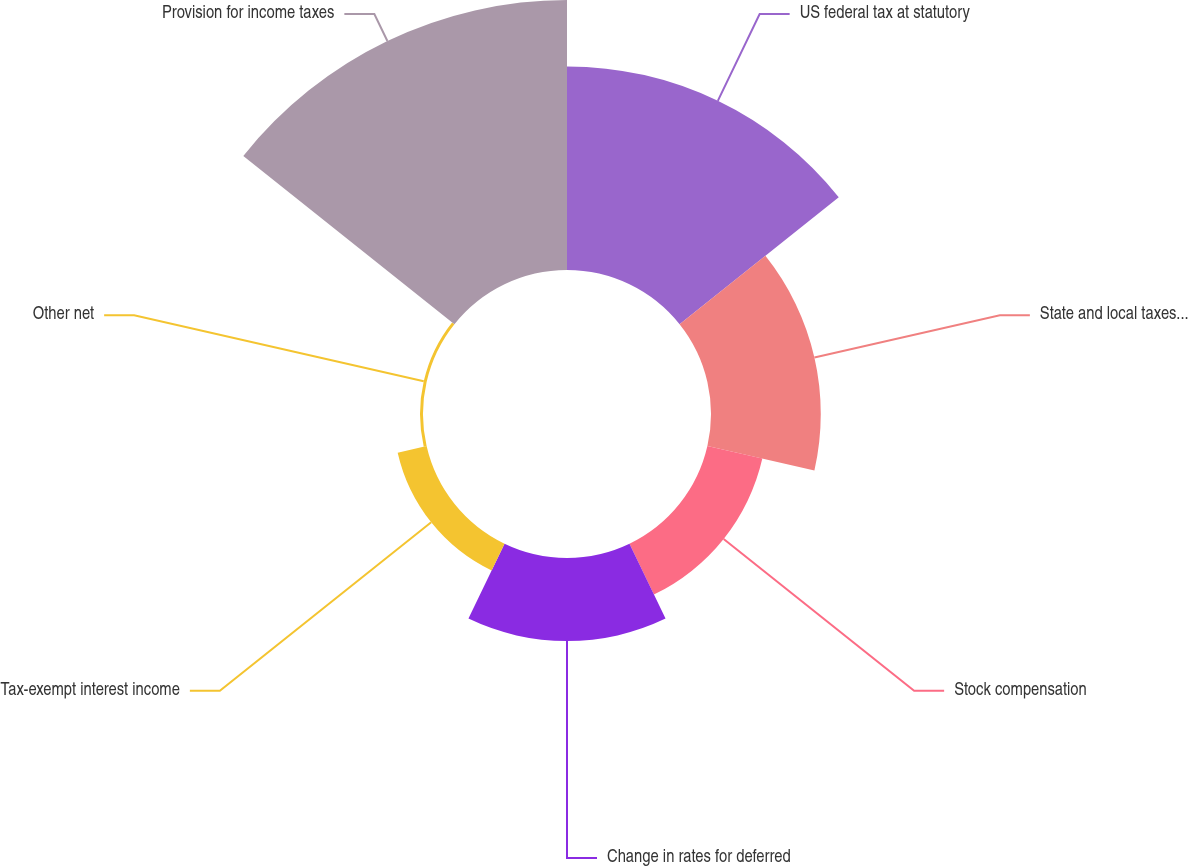Convert chart. <chart><loc_0><loc_0><loc_500><loc_500><pie_chart><fcel>US federal tax at statutory<fcel>State and local taxes - net of<fcel>Stock compensation<fcel>Change in rates for deferred<fcel>Tax-exempt interest income<fcel>Other net<fcel>Provision for income taxes<nl><fcel>26.95%<fcel>14.53%<fcel>7.46%<fcel>11.0%<fcel>3.93%<fcel>0.39%<fcel>35.74%<nl></chart> 